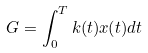Convert formula to latex. <formula><loc_0><loc_0><loc_500><loc_500>G = \int _ { 0 } ^ { T } k ( t ) x ( t ) d t</formula> 